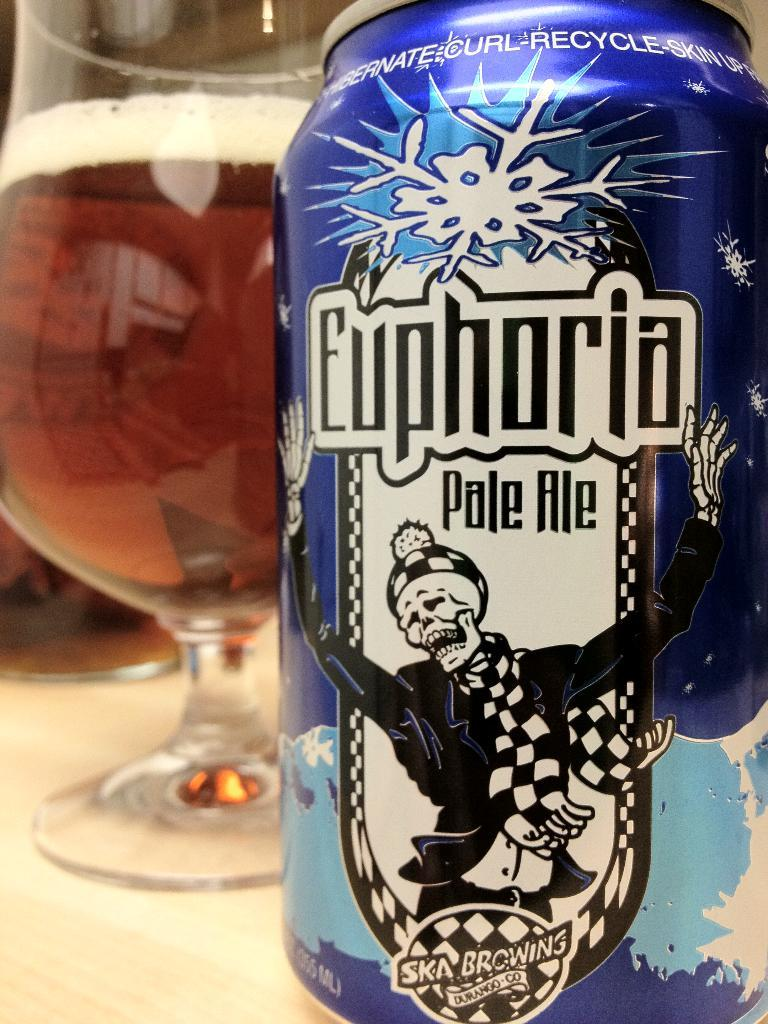<image>
Summarize the visual content of the image. Euphoria is the brand of the beverage can. 